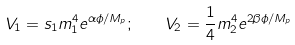<formula> <loc_0><loc_0><loc_500><loc_500>V _ { 1 } = s _ { 1 } m _ { 1 } ^ { 4 } e ^ { \alpha \phi / M _ { p } } ; \quad V _ { 2 } = \frac { 1 } { 4 } m _ { 2 } ^ { 4 } e ^ { 2 \beta \phi / M _ { p } }</formula> 